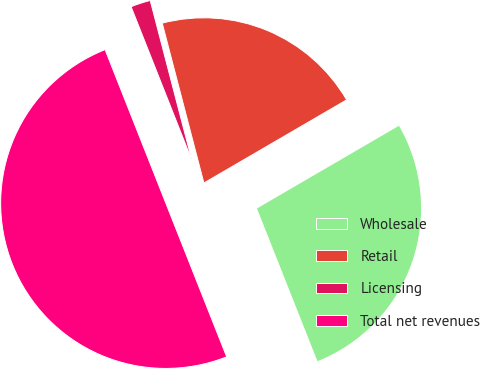<chart> <loc_0><loc_0><loc_500><loc_500><pie_chart><fcel>Wholesale<fcel>Retail<fcel>Licensing<fcel>Total net revenues<nl><fcel>27.39%<fcel>20.66%<fcel>1.94%<fcel>50.0%<nl></chart> 